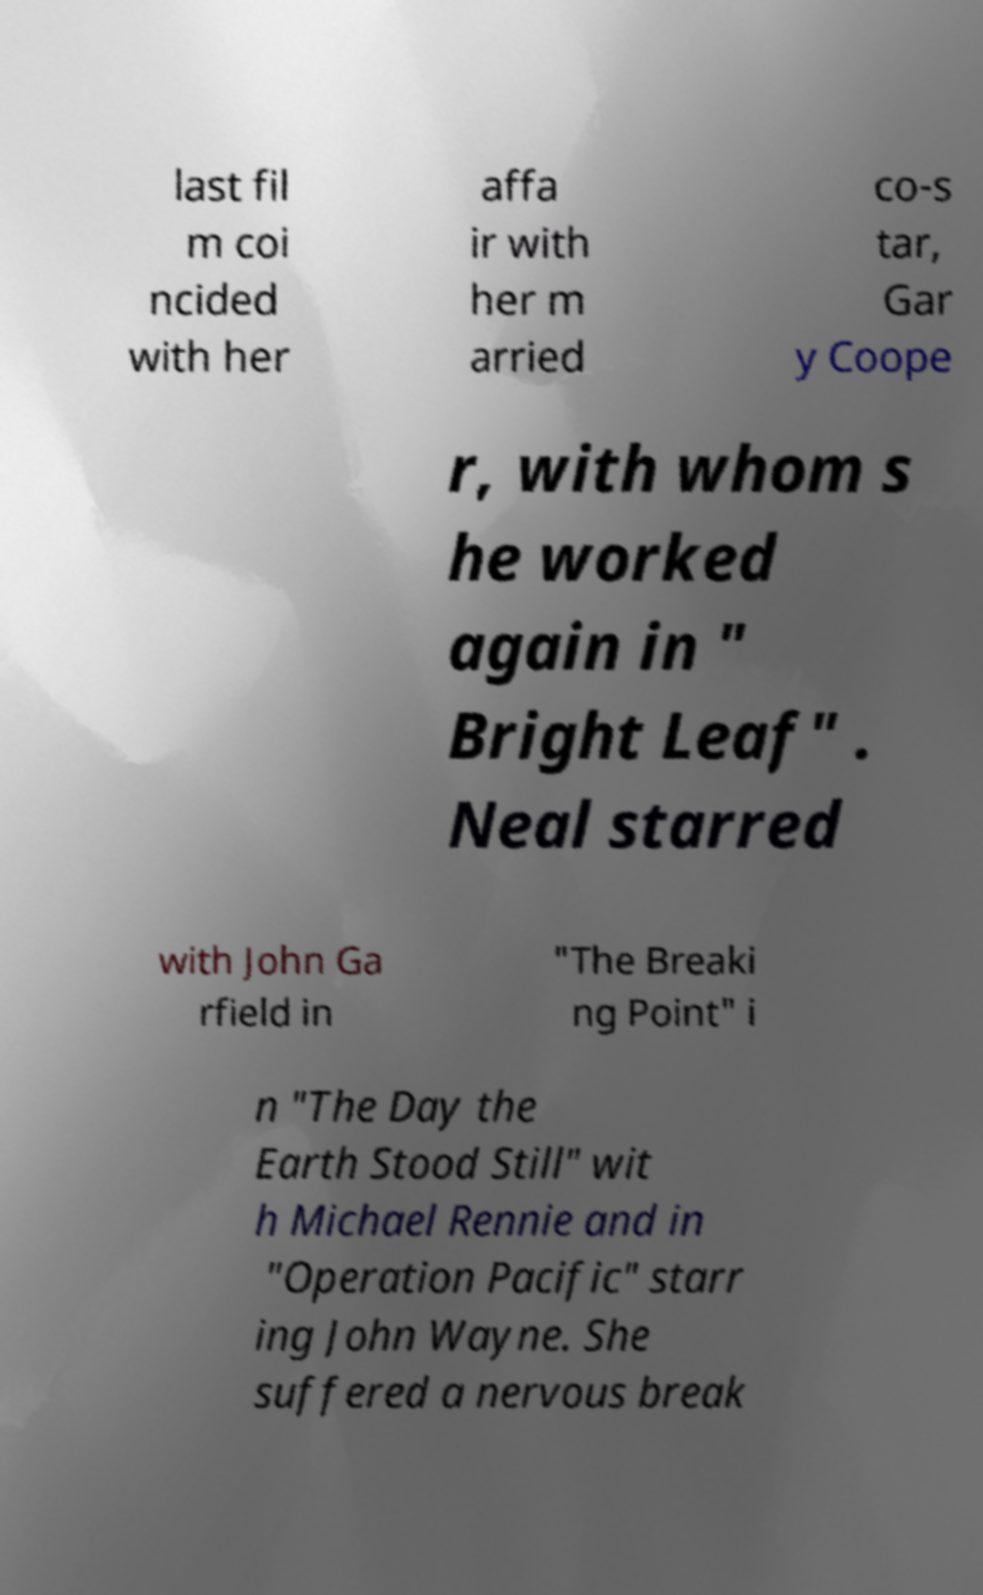There's text embedded in this image that I need extracted. Can you transcribe it verbatim? last fil m coi ncided with her affa ir with her m arried co-s tar, Gar y Coope r, with whom s he worked again in " Bright Leaf" . Neal starred with John Ga rfield in "The Breaki ng Point" i n "The Day the Earth Stood Still" wit h Michael Rennie and in "Operation Pacific" starr ing John Wayne. She suffered a nervous break 